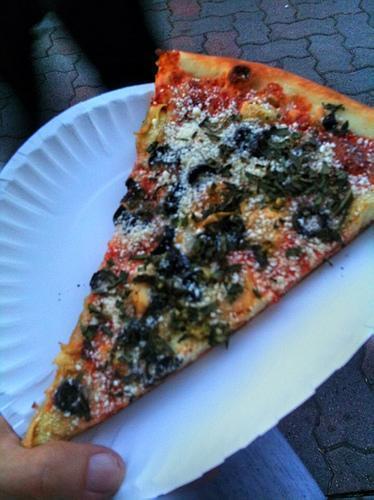How many slices are on the plate?
Give a very brief answer. 1. 